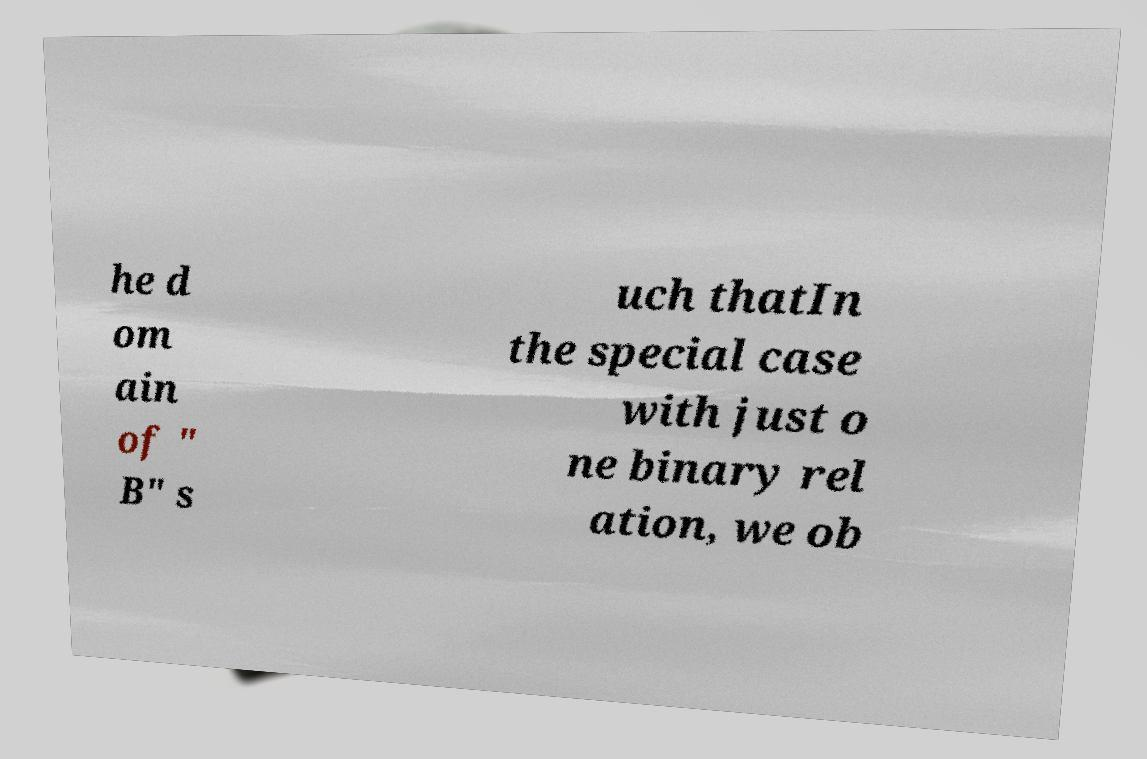Could you extract and type out the text from this image? he d om ain of " B" s uch thatIn the special case with just o ne binary rel ation, we ob 